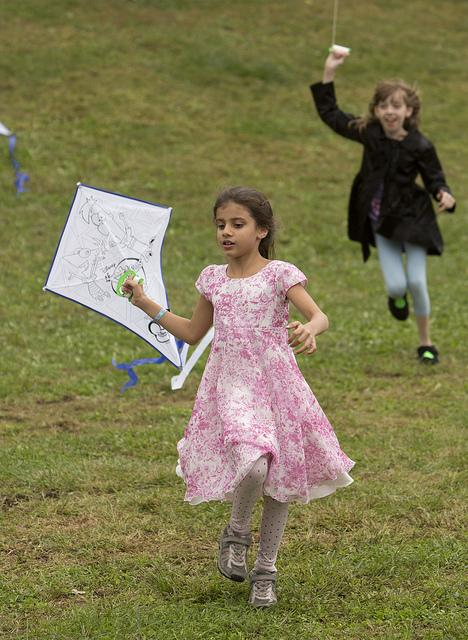What is the girl in pink wearing?

Choices:
A) smock
B) garbage bag
C) dress
D) lab coat dress 